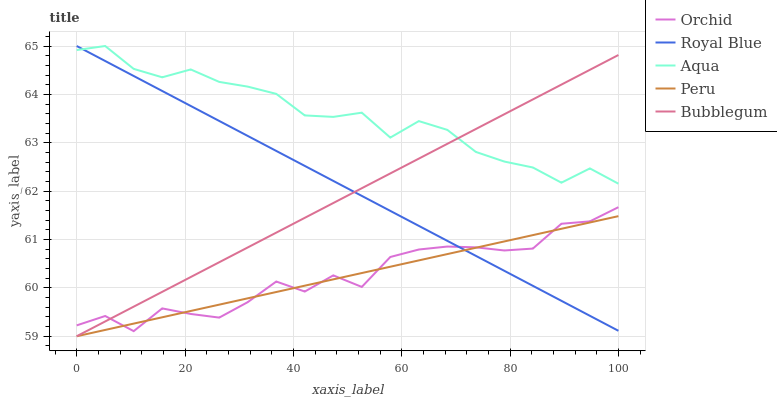Does Peru have the minimum area under the curve?
Answer yes or no. Yes. Does Aqua have the maximum area under the curve?
Answer yes or no. Yes. Does Bubblegum have the minimum area under the curve?
Answer yes or no. No. Does Bubblegum have the maximum area under the curve?
Answer yes or no. No. Is Peru the smoothest?
Answer yes or no. Yes. Is Orchid the roughest?
Answer yes or no. Yes. Is Aqua the smoothest?
Answer yes or no. No. Is Aqua the roughest?
Answer yes or no. No. Does Bubblegum have the lowest value?
Answer yes or no. Yes. Does Aqua have the lowest value?
Answer yes or no. No. Does Aqua have the highest value?
Answer yes or no. Yes. Does Bubblegum have the highest value?
Answer yes or no. No. Is Orchid less than Aqua?
Answer yes or no. Yes. Is Aqua greater than Peru?
Answer yes or no. Yes. Does Royal Blue intersect Bubblegum?
Answer yes or no. Yes. Is Royal Blue less than Bubblegum?
Answer yes or no. No. Is Royal Blue greater than Bubblegum?
Answer yes or no. No. Does Orchid intersect Aqua?
Answer yes or no. No. 